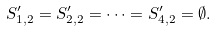Convert formula to latex. <formula><loc_0><loc_0><loc_500><loc_500>S _ { 1 , 2 } ^ { \prime } = S _ { 2 , 2 } ^ { \prime } = \cdots = S _ { 4 , 2 } ^ { \prime } = \emptyset .</formula> 